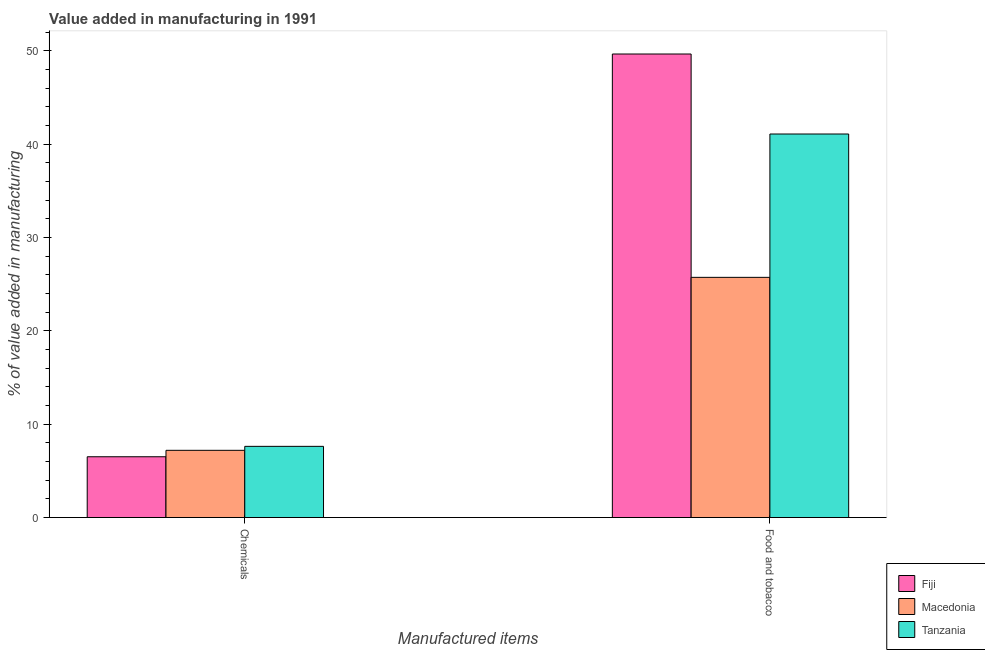How many different coloured bars are there?
Keep it short and to the point. 3. How many bars are there on the 1st tick from the left?
Offer a very short reply. 3. What is the label of the 1st group of bars from the left?
Give a very brief answer. Chemicals. What is the value added by  manufacturing chemicals in Tanzania?
Provide a succinct answer. 7.63. Across all countries, what is the maximum value added by  manufacturing chemicals?
Ensure brevity in your answer.  7.63. Across all countries, what is the minimum value added by  manufacturing chemicals?
Ensure brevity in your answer.  6.51. In which country was the value added by manufacturing food and tobacco maximum?
Offer a terse response. Fiji. In which country was the value added by  manufacturing chemicals minimum?
Your response must be concise. Fiji. What is the total value added by manufacturing food and tobacco in the graph?
Give a very brief answer. 116.5. What is the difference between the value added by manufacturing food and tobacco in Macedonia and that in Fiji?
Your answer should be compact. -23.93. What is the difference between the value added by manufacturing food and tobacco in Macedonia and the value added by  manufacturing chemicals in Tanzania?
Your answer should be compact. 18.11. What is the average value added by  manufacturing chemicals per country?
Give a very brief answer. 7.12. What is the difference between the value added by manufacturing food and tobacco and value added by  manufacturing chemicals in Tanzania?
Your response must be concise. 33.47. What is the ratio of the value added by  manufacturing chemicals in Macedonia to that in Tanzania?
Give a very brief answer. 0.94. Is the value added by manufacturing food and tobacco in Macedonia less than that in Tanzania?
Ensure brevity in your answer.  Yes. What does the 3rd bar from the left in Food and tobacco represents?
Offer a very short reply. Tanzania. What does the 2nd bar from the right in Chemicals represents?
Offer a terse response. Macedonia. Are all the bars in the graph horizontal?
Provide a succinct answer. No. How many countries are there in the graph?
Give a very brief answer. 3. Are the values on the major ticks of Y-axis written in scientific E-notation?
Your answer should be compact. No. Does the graph contain any zero values?
Provide a succinct answer. No. Does the graph contain grids?
Keep it short and to the point. No. How many legend labels are there?
Give a very brief answer. 3. How are the legend labels stacked?
Offer a terse response. Vertical. What is the title of the graph?
Provide a succinct answer. Value added in manufacturing in 1991. Does "Moldova" appear as one of the legend labels in the graph?
Your answer should be compact. No. What is the label or title of the X-axis?
Your answer should be very brief. Manufactured items. What is the label or title of the Y-axis?
Ensure brevity in your answer.  % of value added in manufacturing. What is the % of value added in manufacturing in Fiji in Chemicals?
Your response must be concise. 6.51. What is the % of value added in manufacturing of Macedonia in Chemicals?
Provide a short and direct response. 7.2. What is the % of value added in manufacturing in Tanzania in Chemicals?
Your answer should be very brief. 7.63. What is the % of value added in manufacturing of Fiji in Food and tobacco?
Make the answer very short. 49.67. What is the % of value added in manufacturing in Macedonia in Food and tobacco?
Your answer should be very brief. 25.74. What is the % of value added in manufacturing of Tanzania in Food and tobacco?
Provide a succinct answer. 41.09. Across all Manufactured items, what is the maximum % of value added in manufacturing of Fiji?
Your response must be concise. 49.67. Across all Manufactured items, what is the maximum % of value added in manufacturing of Macedonia?
Your response must be concise. 25.74. Across all Manufactured items, what is the maximum % of value added in manufacturing in Tanzania?
Keep it short and to the point. 41.09. Across all Manufactured items, what is the minimum % of value added in manufacturing in Fiji?
Your answer should be compact. 6.51. Across all Manufactured items, what is the minimum % of value added in manufacturing in Macedonia?
Your answer should be very brief. 7.2. Across all Manufactured items, what is the minimum % of value added in manufacturing of Tanzania?
Provide a succinct answer. 7.63. What is the total % of value added in manufacturing in Fiji in the graph?
Provide a succinct answer. 56.18. What is the total % of value added in manufacturing in Macedonia in the graph?
Offer a terse response. 32.94. What is the total % of value added in manufacturing of Tanzania in the graph?
Keep it short and to the point. 48.72. What is the difference between the % of value added in manufacturing in Fiji in Chemicals and that in Food and tobacco?
Give a very brief answer. -43.15. What is the difference between the % of value added in manufacturing in Macedonia in Chemicals and that in Food and tobacco?
Offer a terse response. -18.53. What is the difference between the % of value added in manufacturing of Tanzania in Chemicals and that in Food and tobacco?
Give a very brief answer. -33.47. What is the difference between the % of value added in manufacturing of Fiji in Chemicals and the % of value added in manufacturing of Macedonia in Food and tobacco?
Provide a succinct answer. -19.22. What is the difference between the % of value added in manufacturing of Fiji in Chemicals and the % of value added in manufacturing of Tanzania in Food and tobacco?
Give a very brief answer. -34.58. What is the difference between the % of value added in manufacturing in Macedonia in Chemicals and the % of value added in manufacturing in Tanzania in Food and tobacco?
Offer a terse response. -33.89. What is the average % of value added in manufacturing in Fiji per Manufactured items?
Your answer should be compact. 28.09. What is the average % of value added in manufacturing in Macedonia per Manufactured items?
Make the answer very short. 16.47. What is the average % of value added in manufacturing in Tanzania per Manufactured items?
Your answer should be compact. 24.36. What is the difference between the % of value added in manufacturing in Fiji and % of value added in manufacturing in Macedonia in Chemicals?
Keep it short and to the point. -0.69. What is the difference between the % of value added in manufacturing of Fiji and % of value added in manufacturing of Tanzania in Chemicals?
Your response must be concise. -1.11. What is the difference between the % of value added in manufacturing of Macedonia and % of value added in manufacturing of Tanzania in Chemicals?
Offer a terse response. -0.42. What is the difference between the % of value added in manufacturing of Fiji and % of value added in manufacturing of Macedonia in Food and tobacco?
Keep it short and to the point. 23.93. What is the difference between the % of value added in manufacturing in Fiji and % of value added in manufacturing in Tanzania in Food and tobacco?
Your answer should be compact. 8.57. What is the difference between the % of value added in manufacturing in Macedonia and % of value added in manufacturing in Tanzania in Food and tobacco?
Your response must be concise. -15.36. What is the ratio of the % of value added in manufacturing of Fiji in Chemicals to that in Food and tobacco?
Your answer should be compact. 0.13. What is the ratio of the % of value added in manufacturing of Macedonia in Chemicals to that in Food and tobacco?
Ensure brevity in your answer.  0.28. What is the ratio of the % of value added in manufacturing of Tanzania in Chemicals to that in Food and tobacco?
Your answer should be very brief. 0.19. What is the difference between the highest and the second highest % of value added in manufacturing of Fiji?
Keep it short and to the point. 43.15. What is the difference between the highest and the second highest % of value added in manufacturing of Macedonia?
Make the answer very short. 18.53. What is the difference between the highest and the second highest % of value added in manufacturing in Tanzania?
Your answer should be very brief. 33.47. What is the difference between the highest and the lowest % of value added in manufacturing of Fiji?
Your answer should be very brief. 43.15. What is the difference between the highest and the lowest % of value added in manufacturing in Macedonia?
Your answer should be very brief. 18.53. What is the difference between the highest and the lowest % of value added in manufacturing of Tanzania?
Ensure brevity in your answer.  33.47. 